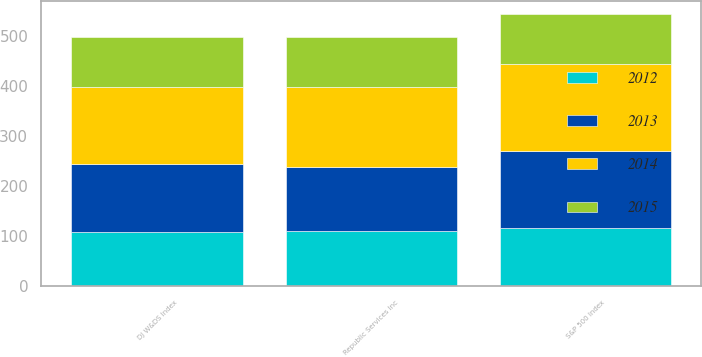Convert chart to OTSL. <chart><loc_0><loc_0><loc_500><loc_500><stacked_bar_chart><ecel><fcel>Republic Services Inc<fcel>S&P 500 Index<fcel>DJ W&DS Index<nl><fcel>2015<fcel>100<fcel>100<fcel>100<nl><fcel>2012<fcel>110.01<fcel>116<fcel>108.5<nl><fcel>2013<fcel>128.3<fcel>153.57<fcel>135.56<nl><fcel>2014<fcel>160.05<fcel>174.6<fcel>154.2<nl></chart> 